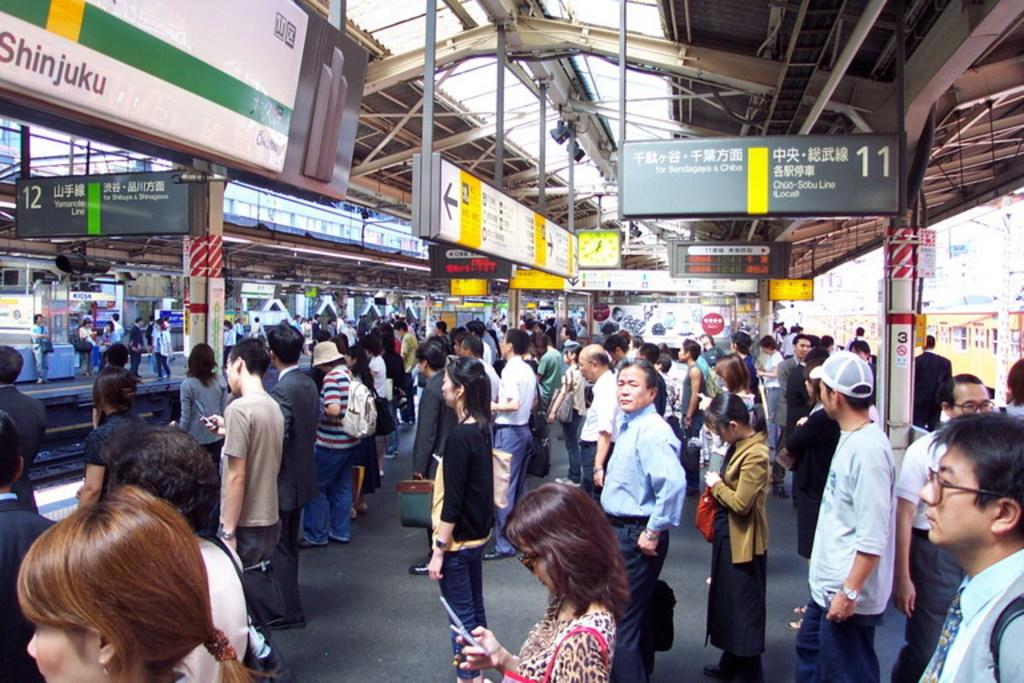What are the people in the image doing? There is a group of people standing on a platform in the image. What objects can be seen in the image besides the people? There are boards, a display screen, a clock, poles, and lights in the image. What type of glove is being used to play the string instrument in the image? There is no glove or string instrument present in the image. What type of shop can be seen in the background of the image? There is no shop visible in the image. 